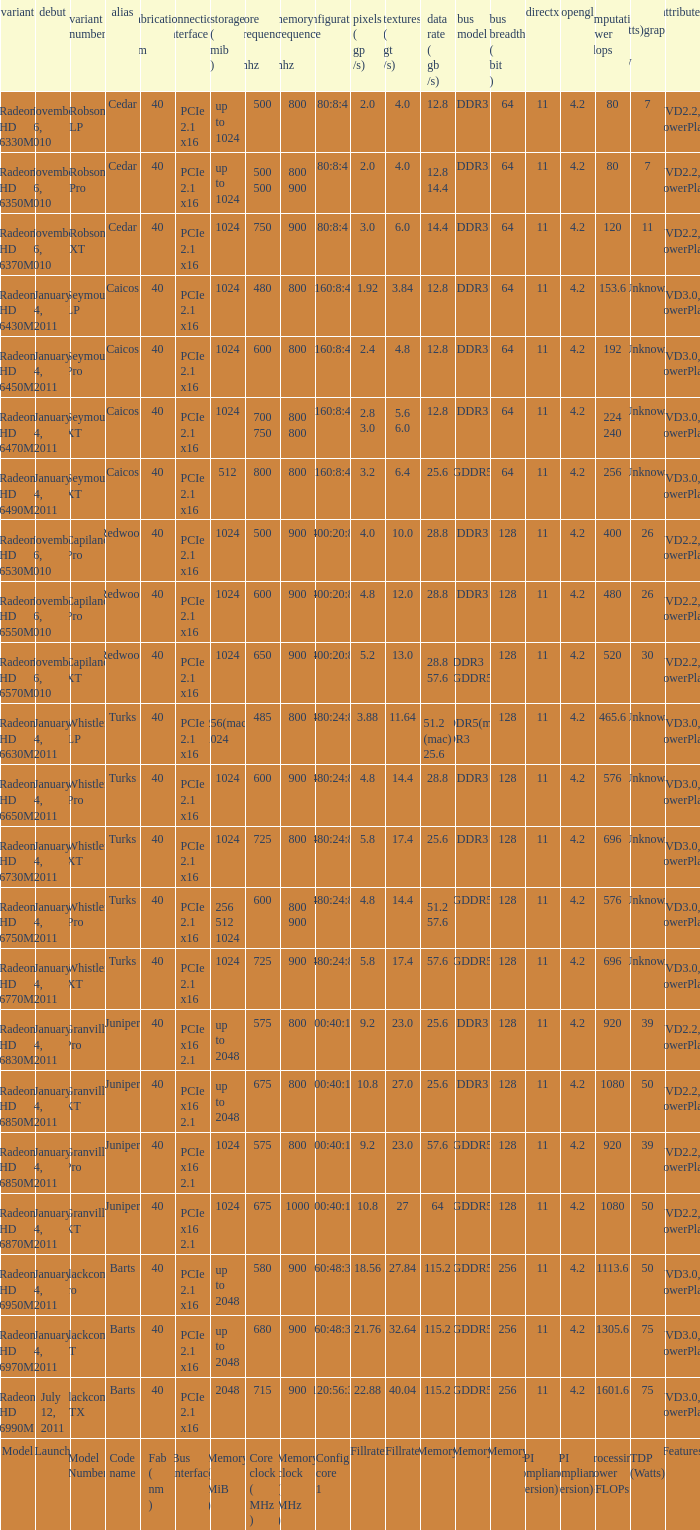What is every code name for the model Radeon HD 6650m? Turks. 